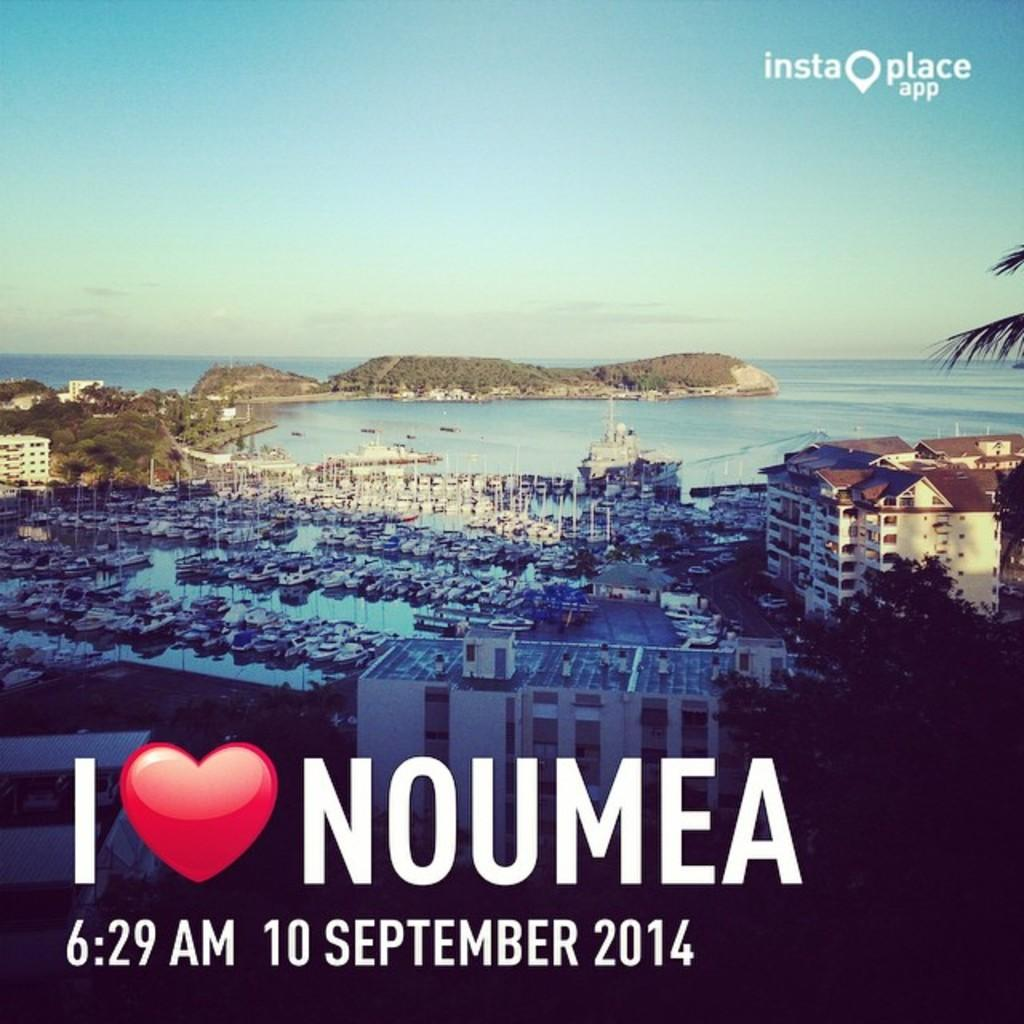<image>
Give a short and clear explanation of the subsequent image. I love Noumea insta place app that have the time and date 